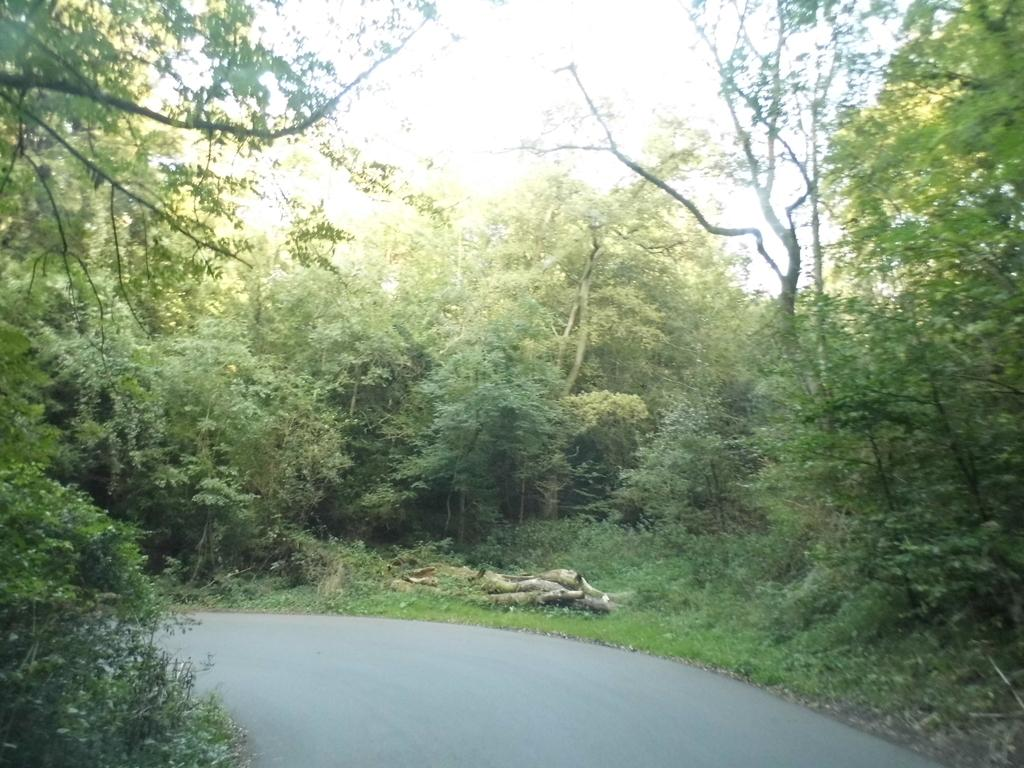What can be seen in the foreground of the picture? In the foreground of the picture, there are plants, grass, and a road. What is located in the center of the picture? In the center of the picture, there are trees, plants, and wood. What type of food is being prepared on the wood in the center of the picture? There is no food preparation or cooking activity visible in the image; it only shows plants, trees, and wood. Can you see a house in the picture? There is no house present in the image; it features plants, grass, a road, trees, plants, and wood. 